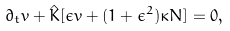Convert formula to latex. <formula><loc_0><loc_0><loc_500><loc_500>\partial _ { t } { v } + \hat { K } [ \epsilon { v } + ( 1 + \epsilon ^ { 2 } ) \kappa { N } ] = 0 ,</formula> 